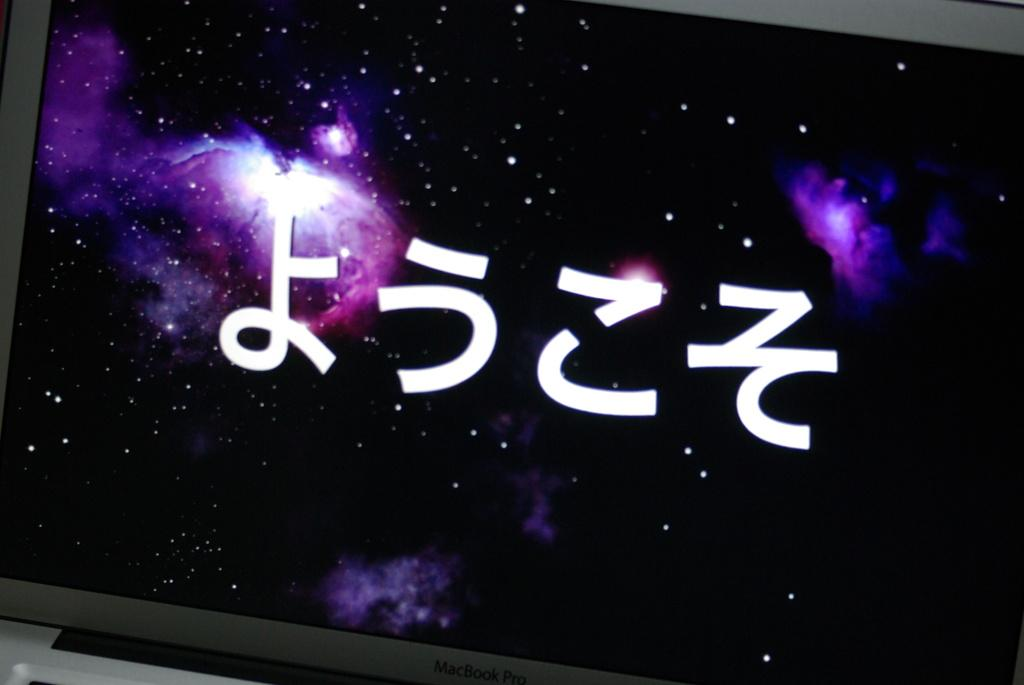What type of image is being described? The image is a desktop screen. What can be seen on the desktop screen? There is text displayed on the screen. Is there any smoke visible on the desktop screen? No, there is no smoke visible on the desktop screen. Can you provide an example of the text displayed on the screen? The facts do not provide any specific information about the text displayed on the screen, so it is not possible to provide an example. 